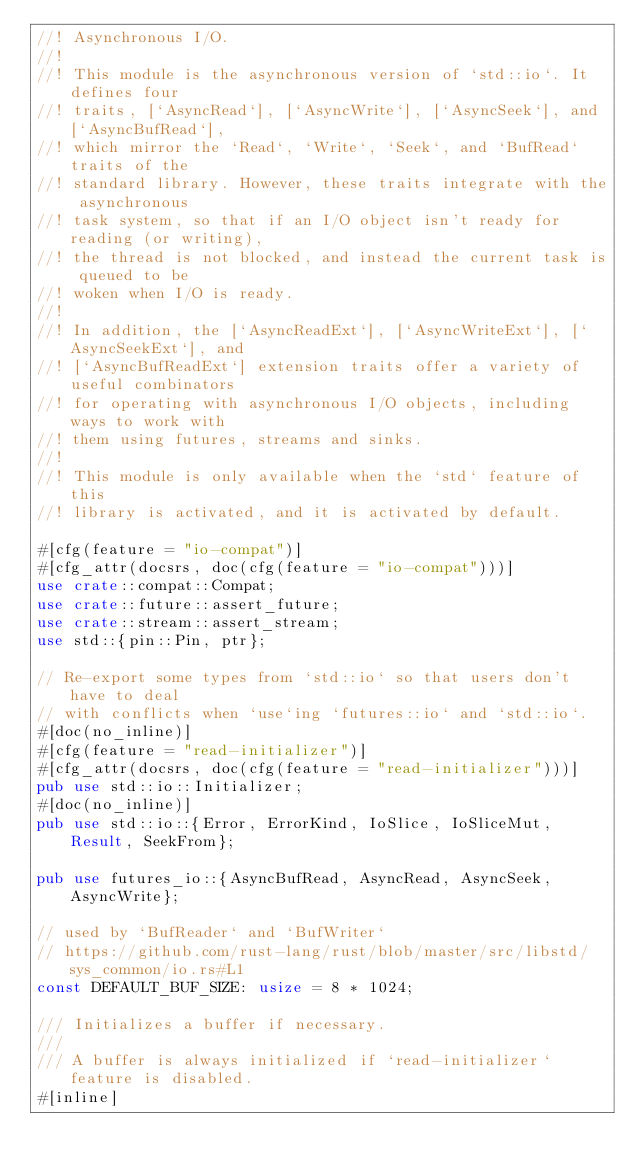Convert code to text. <code><loc_0><loc_0><loc_500><loc_500><_Rust_>//! Asynchronous I/O.
//!
//! This module is the asynchronous version of `std::io`. It defines four
//! traits, [`AsyncRead`], [`AsyncWrite`], [`AsyncSeek`], and [`AsyncBufRead`],
//! which mirror the `Read`, `Write`, `Seek`, and `BufRead` traits of the
//! standard library. However, these traits integrate with the asynchronous
//! task system, so that if an I/O object isn't ready for reading (or writing),
//! the thread is not blocked, and instead the current task is queued to be
//! woken when I/O is ready.
//!
//! In addition, the [`AsyncReadExt`], [`AsyncWriteExt`], [`AsyncSeekExt`], and
//! [`AsyncBufReadExt`] extension traits offer a variety of useful combinators
//! for operating with asynchronous I/O objects, including ways to work with
//! them using futures, streams and sinks.
//!
//! This module is only available when the `std` feature of this
//! library is activated, and it is activated by default.

#[cfg(feature = "io-compat")]
#[cfg_attr(docsrs, doc(cfg(feature = "io-compat")))]
use crate::compat::Compat;
use crate::future::assert_future;
use crate::stream::assert_stream;
use std::{pin::Pin, ptr};

// Re-export some types from `std::io` so that users don't have to deal
// with conflicts when `use`ing `futures::io` and `std::io`.
#[doc(no_inline)]
#[cfg(feature = "read-initializer")]
#[cfg_attr(docsrs, doc(cfg(feature = "read-initializer")))]
pub use std::io::Initializer;
#[doc(no_inline)]
pub use std::io::{Error, ErrorKind, IoSlice, IoSliceMut, Result, SeekFrom};

pub use futures_io::{AsyncBufRead, AsyncRead, AsyncSeek, AsyncWrite};

// used by `BufReader` and `BufWriter`
// https://github.com/rust-lang/rust/blob/master/src/libstd/sys_common/io.rs#L1
const DEFAULT_BUF_SIZE: usize = 8 * 1024;

/// Initializes a buffer if necessary.
///
/// A buffer is always initialized if `read-initializer` feature is disabled.
#[inline]</code> 